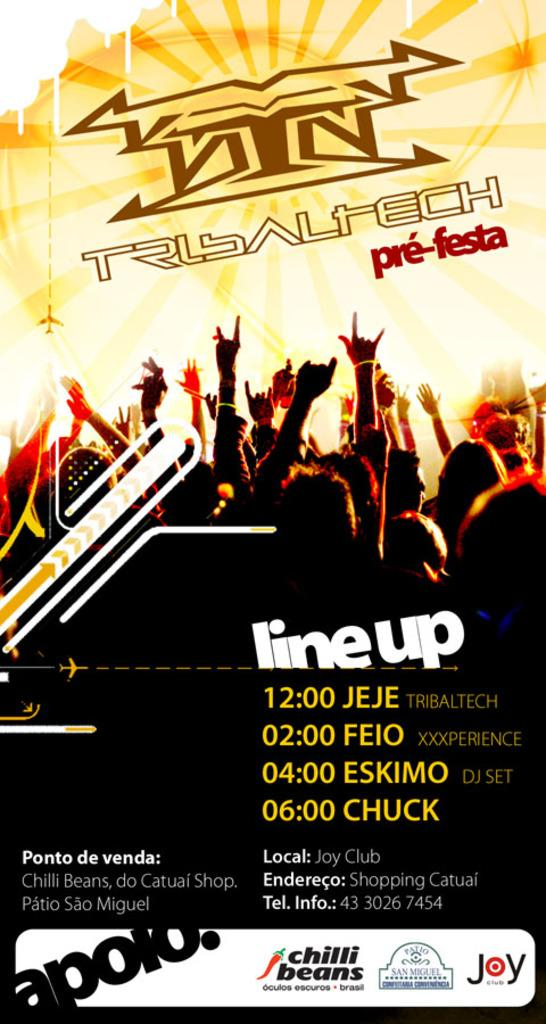<image>
Summarize the visual content of the image. An advertisement for the concert line-ups that start at 12:00 and end at 6:00. 